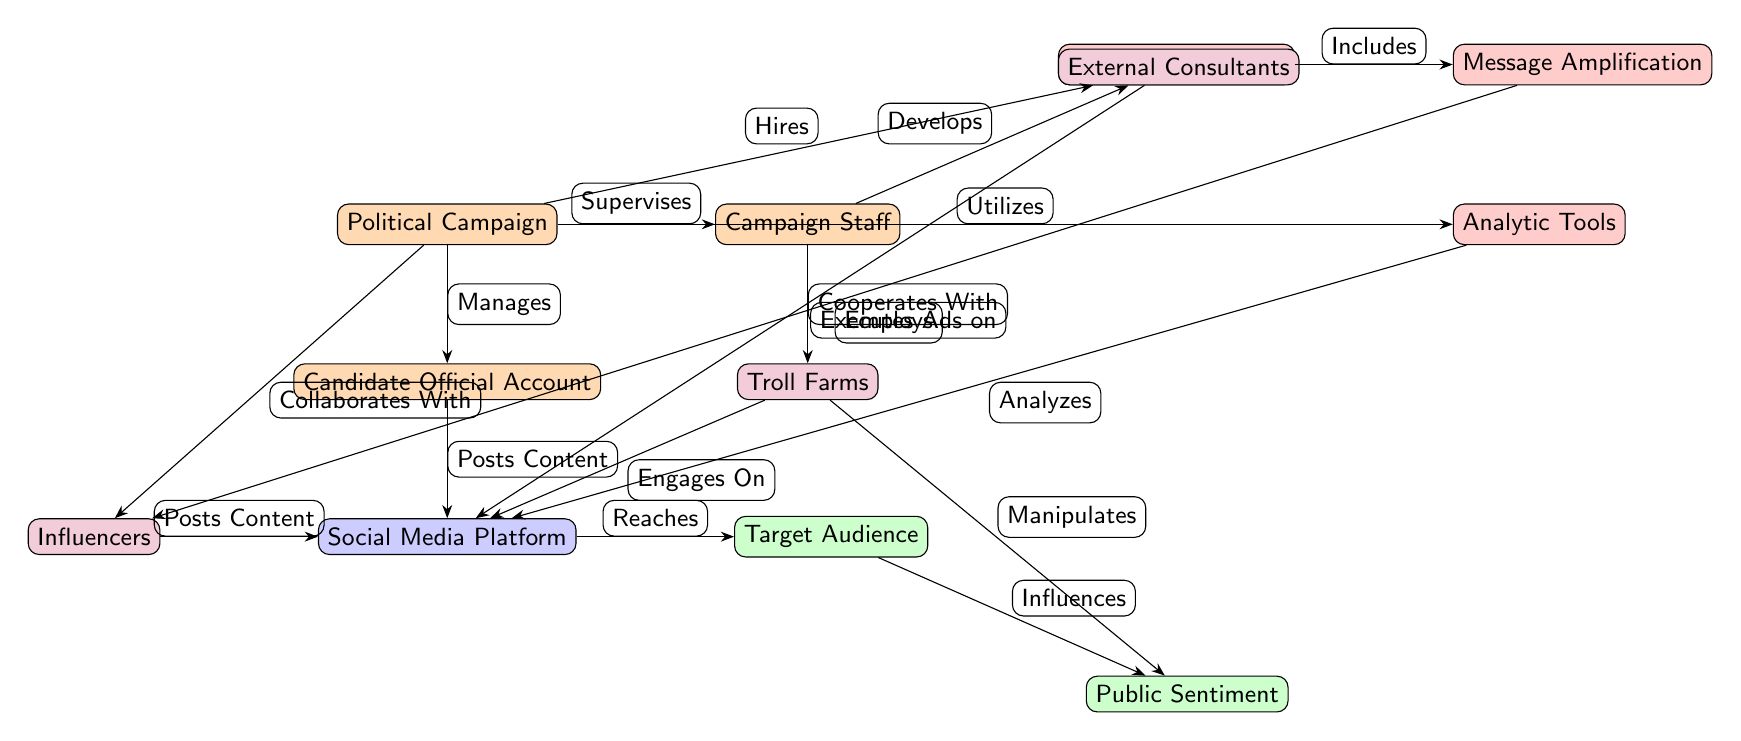What is the central node of the influence network? The diagram presents a political campaign as the central focus through which many relationships are channeled. It manages the candidate official account and supervises the campaign staff, indicating its foundational role.
Answer: Political Campaign How many nodes are there in the diagram? By counting the distinct entities displayed in the diagram, we find that there are a total of 12 nodes: Political Campaign, Candidate Official Account, Campaign Staff, Social Media Platform, Influencers, Target Audience, Advertising Strategy, Analytic Tools, Message Amplification, Public Sentiment, External Consultants, and Troll Farms.
Answer: 12 Which entities directly influence Public Sentiment? Tracing the connections, we observe that the Target Audience influences Public Sentiment, and the Troll Farms also have a manipulative relationship with it, showing two distinct paths of influence.
Answer: Target Audience, Troll Farms What type of relationship does the Campaign Staff have with External Consultants? The diagram illustrates a direct connection by indicating that the Political Campaign "Hires" the External Consultants, which suggests a supportive or advisory relationship between them.
Answer: Hires What does the Advertising Strategy include? In the diagram, the Advertising Strategy is shown to include Message Amplification, representing that the strategy encompasses methods to enhance the reach of campaign messages.
Answer: Message Amplification How many edges connect the Social Media Platform directly? Analyzing the edges leading to and from the Social Media Platform, we find that it connects to three nodes: Candidate Official Account, Influencers, and Target Audience, leading to a total of 4 directed edges.
Answer: 4 Which role develops the Advertising Strategy? The diagram specifies that the Campaign Staff develops the Advertising Strategy, indicating their responsibility for formulating how to advertise on social media platforms.
Answer: Campaign Staff What is the primary function of Troll Farms in this network? Troll Farms are depicted as entities that engage on the Social Media Platform and manipulate Public Sentiment, suggesting their disruptive role in affecting public discourse.
Answer: Manipulates 